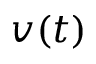<formula> <loc_0><loc_0><loc_500><loc_500>v ( t )</formula> 